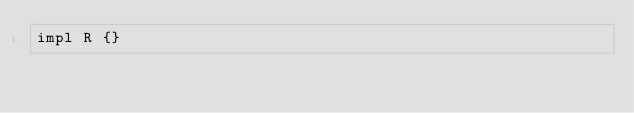<code> <loc_0><loc_0><loc_500><loc_500><_Rust_>impl R {}
</code> 